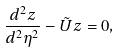<formula> <loc_0><loc_0><loc_500><loc_500>\frac { d ^ { 2 } z } { d ^ { 2 } \eta ^ { 2 } } - \tilde { U } z = 0 ,</formula> 